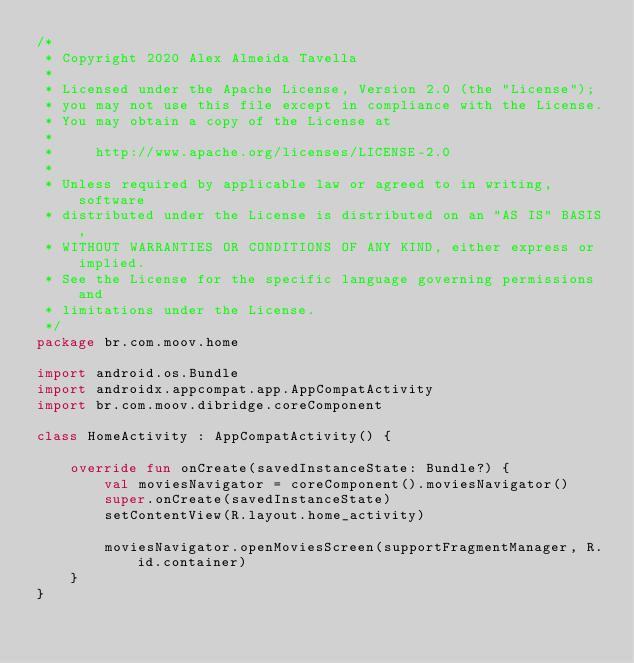<code> <loc_0><loc_0><loc_500><loc_500><_Kotlin_>/*
 * Copyright 2020 Alex Almeida Tavella
 *
 * Licensed under the Apache License, Version 2.0 (the "License");
 * you may not use this file except in compliance with the License.
 * You may obtain a copy of the License at
 *
 *     http://www.apache.org/licenses/LICENSE-2.0
 *
 * Unless required by applicable law or agreed to in writing, software
 * distributed under the License is distributed on an "AS IS" BASIS,
 * WITHOUT WARRANTIES OR CONDITIONS OF ANY KIND, either express or implied.
 * See the License for the specific language governing permissions and
 * limitations under the License.
 */
package br.com.moov.home

import android.os.Bundle
import androidx.appcompat.app.AppCompatActivity
import br.com.moov.dibridge.coreComponent

class HomeActivity : AppCompatActivity() {

    override fun onCreate(savedInstanceState: Bundle?) {
        val moviesNavigator = coreComponent().moviesNavigator()
        super.onCreate(savedInstanceState)
        setContentView(R.layout.home_activity)

        moviesNavigator.openMoviesScreen(supportFragmentManager, R.id.container)
    }
}
</code> 